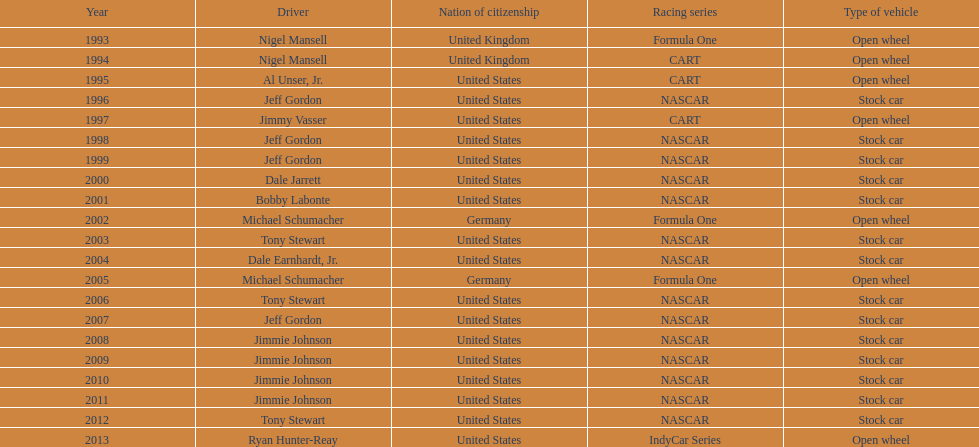Jimmy johnson won how many consecutive espy awards? 4. 